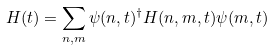<formula> <loc_0><loc_0><loc_500><loc_500>H ( t ) = \sum _ { n , m } \psi ( n , t ) ^ { \dagger } H ( n , m , t ) \psi ( m , t )</formula> 